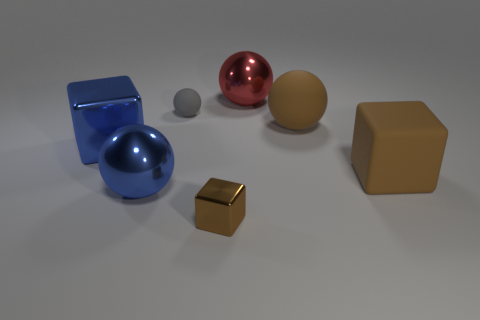What size is the matte ball that is the same color as the tiny metal object?
Your response must be concise. Large. There is a metallic thing on the right side of the small brown shiny thing; is its shape the same as the small object that is behind the blue metal ball?
Ensure brevity in your answer.  Yes. Is there a tiny brown metal cube?
Your answer should be compact. Yes. There is another small thing that is the same shape as the red thing; what color is it?
Offer a terse response. Gray. There is a object that is the same size as the gray matte ball; what is its color?
Offer a terse response. Brown. Do the red sphere and the blue cube have the same material?
Keep it short and to the point. Yes. What number of tiny rubber spheres have the same color as the small metallic block?
Your response must be concise. 0. Do the tiny metal thing and the large rubber cube have the same color?
Give a very brief answer. Yes. There is a big sphere that is to the right of the large red object; what is it made of?
Your answer should be very brief. Rubber. How many large objects are either red blocks or blue metal objects?
Offer a very short reply. 2. 